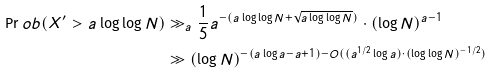<formula> <loc_0><loc_0><loc_500><loc_500>\Pr o b ( X ^ { \prime } > a \log \log N ) & \gg _ { a } \frac { 1 } { 5 } a ^ { - ( a \log \log N + \sqrt { a \log \log N } ) } \cdot ( \log N ) ^ { a - 1 } \\ & \gg ( \log N ) ^ { - ( a \log a - a + 1 ) - O ( ( a ^ { 1 / 2 } \log a ) \cdot ( \log \log N ) ^ { - 1 / 2 } ) }</formula> 